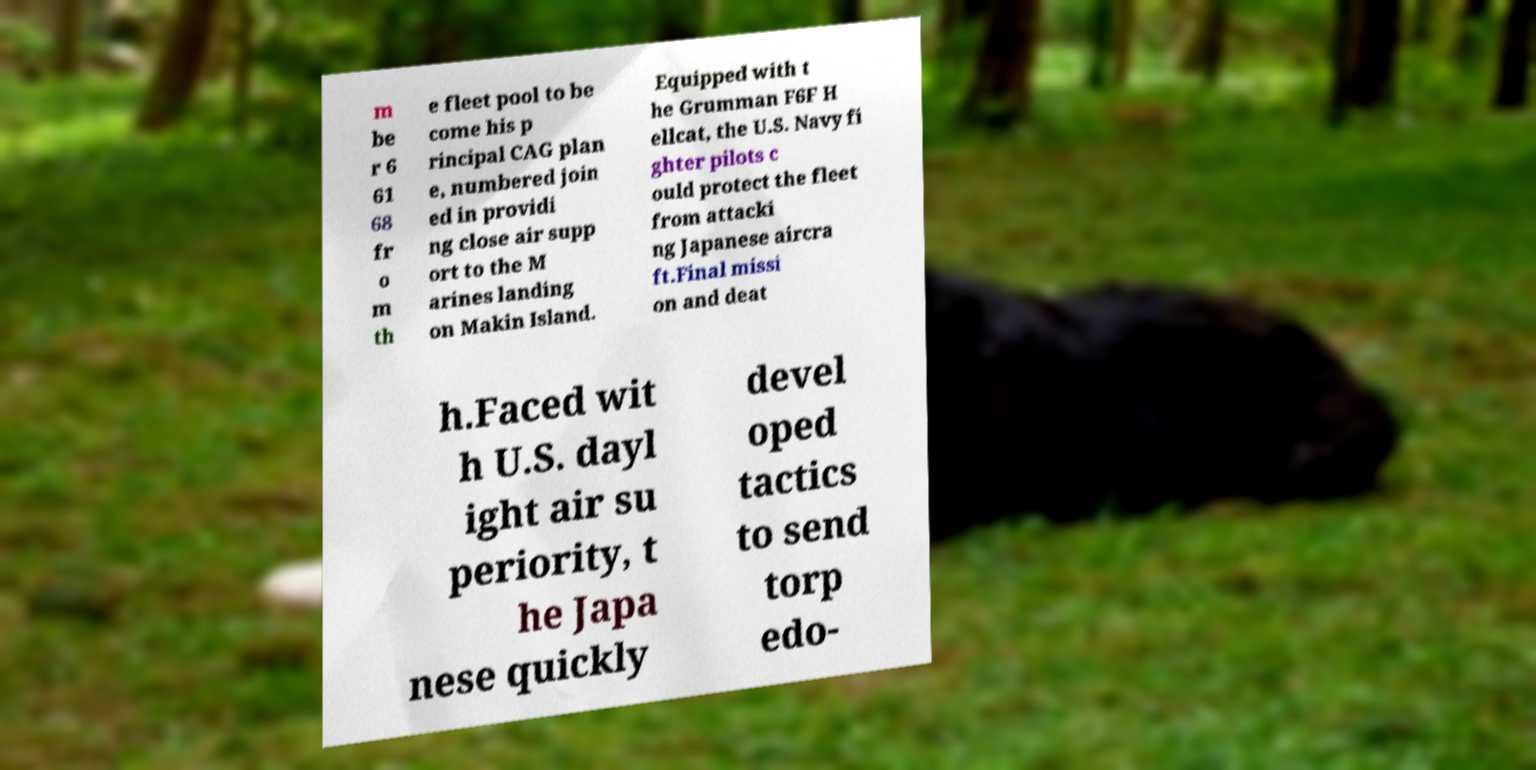There's text embedded in this image that I need extracted. Can you transcribe it verbatim? m be r 6 61 68 fr o m th e fleet pool to be come his p rincipal CAG plan e, numbered join ed in providi ng close air supp ort to the M arines landing on Makin Island. Equipped with t he Grumman F6F H ellcat, the U.S. Navy fi ghter pilots c ould protect the fleet from attacki ng Japanese aircra ft.Final missi on and deat h.Faced wit h U.S. dayl ight air su periority, t he Japa nese quickly devel oped tactics to send torp edo- 